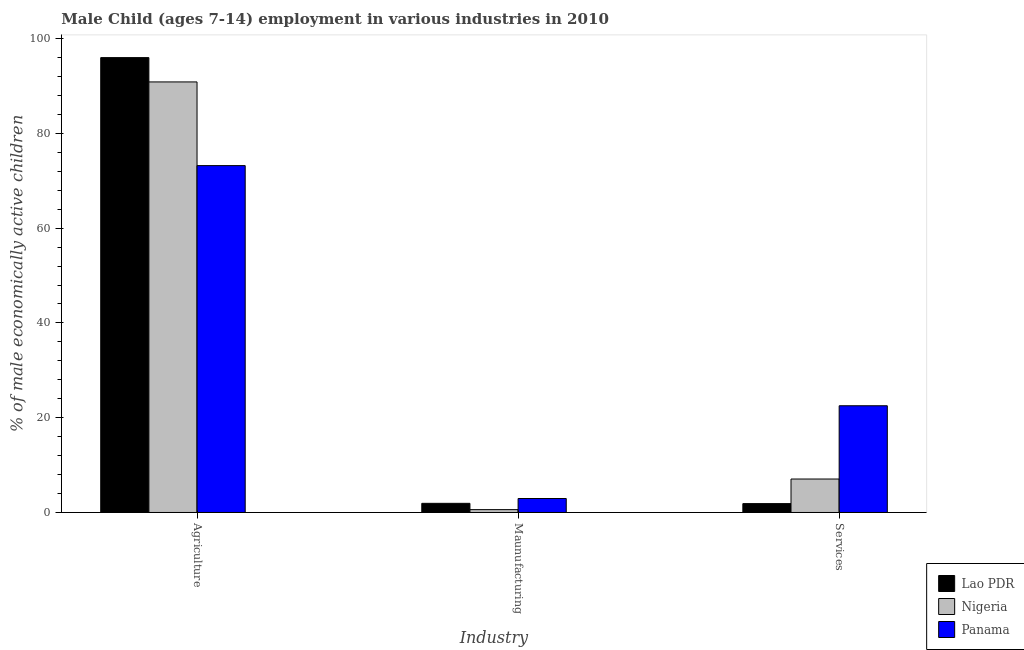How many groups of bars are there?
Provide a short and direct response. 3. Are the number of bars per tick equal to the number of legend labels?
Provide a succinct answer. Yes. How many bars are there on the 3rd tick from the left?
Give a very brief answer. 3. What is the label of the 3rd group of bars from the left?
Your answer should be compact. Services. What is the percentage of economically active children in services in Lao PDR?
Make the answer very short. 1.87. Across all countries, what is the maximum percentage of economically active children in agriculture?
Your response must be concise. 95.98. Across all countries, what is the minimum percentage of economically active children in services?
Offer a terse response. 1.87. In which country was the percentage of economically active children in services maximum?
Your answer should be compact. Panama. In which country was the percentage of economically active children in services minimum?
Make the answer very short. Lao PDR. What is the total percentage of economically active children in services in the graph?
Ensure brevity in your answer.  31.45. What is the difference between the percentage of economically active children in services in Lao PDR and that in Nigeria?
Keep it short and to the point. -5.19. What is the difference between the percentage of economically active children in agriculture in Panama and the percentage of economically active children in services in Nigeria?
Your answer should be compact. 66.13. What is the average percentage of economically active children in services per country?
Keep it short and to the point. 10.48. What is the difference between the percentage of economically active children in manufacturing and percentage of economically active children in services in Nigeria?
Your response must be concise. -6.46. What is the ratio of the percentage of economically active children in services in Panama to that in Nigeria?
Provide a short and direct response. 3.19. Is the difference between the percentage of economically active children in manufacturing in Nigeria and Lao PDR greater than the difference between the percentage of economically active children in agriculture in Nigeria and Lao PDR?
Your answer should be very brief. Yes. What is the difference between the highest and the second highest percentage of economically active children in manufacturing?
Ensure brevity in your answer.  1.02. What is the difference between the highest and the lowest percentage of economically active children in manufacturing?
Your response must be concise. 2.35. In how many countries, is the percentage of economically active children in agriculture greater than the average percentage of economically active children in agriculture taken over all countries?
Make the answer very short. 2. Is the sum of the percentage of economically active children in manufacturing in Lao PDR and Panama greater than the maximum percentage of economically active children in services across all countries?
Your answer should be compact. No. What does the 1st bar from the left in Agriculture represents?
Make the answer very short. Lao PDR. What does the 2nd bar from the right in Maunufacturing represents?
Ensure brevity in your answer.  Nigeria. Is it the case that in every country, the sum of the percentage of economically active children in agriculture and percentage of economically active children in manufacturing is greater than the percentage of economically active children in services?
Provide a succinct answer. Yes. How many bars are there?
Ensure brevity in your answer.  9. Are all the bars in the graph horizontal?
Your answer should be very brief. No. How many countries are there in the graph?
Provide a short and direct response. 3. What is the title of the graph?
Your answer should be very brief. Male Child (ages 7-14) employment in various industries in 2010. Does "French Polynesia" appear as one of the legend labels in the graph?
Keep it short and to the point. No. What is the label or title of the X-axis?
Provide a succinct answer. Industry. What is the label or title of the Y-axis?
Offer a very short reply. % of male economically active children. What is the % of male economically active children of Lao PDR in Agriculture?
Make the answer very short. 95.98. What is the % of male economically active children of Nigeria in Agriculture?
Give a very brief answer. 90.85. What is the % of male economically active children of Panama in Agriculture?
Offer a terse response. 73.19. What is the % of male economically active children of Lao PDR in Maunufacturing?
Ensure brevity in your answer.  1.93. What is the % of male economically active children of Nigeria in Maunufacturing?
Make the answer very short. 0.6. What is the % of male economically active children in Panama in Maunufacturing?
Your response must be concise. 2.95. What is the % of male economically active children of Lao PDR in Services?
Your response must be concise. 1.87. What is the % of male economically active children of Nigeria in Services?
Your answer should be compact. 7.06. What is the % of male economically active children of Panama in Services?
Keep it short and to the point. 22.52. Across all Industry, what is the maximum % of male economically active children in Lao PDR?
Your answer should be compact. 95.98. Across all Industry, what is the maximum % of male economically active children in Nigeria?
Your answer should be very brief. 90.85. Across all Industry, what is the maximum % of male economically active children of Panama?
Offer a terse response. 73.19. Across all Industry, what is the minimum % of male economically active children of Lao PDR?
Keep it short and to the point. 1.87. Across all Industry, what is the minimum % of male economically active children in Nigeria?
Provide a short and direct response. 0.6. Across all Industry, what is the minimum % of male economically active children in Panama?
Offer a terse response. 2.95. What is the total % of male economically active children in Lao PDR in the graph?
Offer a very short reply. 99.78. What is the total % of male economically active children of Nigeria in the graph?
Give a very brief answer. 98.51. What is the total % of male economically active children in Panama in the graph?
Your answer should be very brief. 98.66. What is the difference between the % of male economically active children of Lao PDR in Agriculture and that in Maunufacturing?
Your response must be concise. 94.05. What is the difference between the % of male economically active children in Nigeria in Agriculture and that in Maunufacturing?
Your answer should be very brief. 90.25. What is the difference between the % of male economically active children of Panama in Agriculture and that in Maunufacturing?
Provide a succinct answer. 70.24. What is the difference between the % of male economically active children of Lao PDR in Agriculture and that in Services?
Keep it short and to the point. 94.11. What is the difference between the % of male economically active children in Nigeria in Agriculture and that in Services?
Ensure brevity in your answer.  83.79. What is the difference between the % of male economically active children of Panama in Agriculture and that in Services?
Your response must be concise. 50.67. What is the difference between the % of male economically active children of Lao PDR in Maunufacturing and that in Services?
Give a very brief answer. 0.06. What is the difference between the % of male economically active children in Nigeria in Maunufacturing and that in Services?
Offer a terse response. -6.46. What is the difference between the % of male economically active children in Panama in Maunufacturing and that in Services?
Offer a terse response. -19.57. What is the difference between the % of male economically active children of Lao PDR in Agriculture and the % of male economically active children of Nigeria in Maunufacturing?
Give a very brief answer. 95.38. What is the difference between the % of male economically active children of Lao PDR in Agriculture and the % of male economically active children of Panama in Maunufacturing?
Keep it short and to the point. 93.03. What is the difference between the % of male economically active children of Nigeria in Agriculture and the % of male economically active children of Panama in Maunufacturing?
Your answer should be very brief. 87.9. What is the difference between the % of male economically active children in Lao PDR in Agriculture and the % of male economically active children in Nigeria in Services?
Offer a very short reply. 88.92. What is the difference between the % of male economically active children of Lao PDR in Agriculture and the % of male economically active children of Panama in Services?
Offer a very short reply. 73.46. What is the difference between the % of male economically active children of Nigeria in Agriculture and the % of male economically active children of Panama in Services?
Provide a succinct answer. 68.33. What is the difference between the % of male economically active children of Lao PDR in Maunufacturing and the % of male economically active children of Nigeria in Services?
Your answer should be compact. -5.13. What is the difference between the % of male economically active children in Lao PDR in Maunufacturing and the % of male economically active children in Panama in Services?
Your response must be concise. -20.59. What is the difference between the % of male economically active children in Nigeria in Maunufacturing and the % of male economically active children in Panama in Services?
Make the answer very short. -21.92. What is the average % of male economically active children of Lao PDR per Industry?
Your response must be concise. 33.26. What is the average % of male economically active children in Nigeria per Industry?
Your answer should be very brief. 32.84. What is the average % of male economically active children of Panama per Industry?
Provide a short and direct response. 32.89. What is the difference between the % of male economically active children of Lao PDR and % of male economically active children of Nigeria in Agriculture?
Ensure brevity in your answer.  5.13. What is the difference between the % of male economically active children in Lao PDR and % of male economically active children in Panama in Agriculture?
Make the answer very short. 22.79. What is the difference between the % of male economically active children of Nigeria and % of male economically active children of Panama in Agriculture?
Make the answer very short. 17.66. What is the difference between the % of male economically active children of Lao PDR and % of male economically active children of Nigeria in Maunufacturing?
Ensure brevity in your answer.  1.33. What is the difference between the % of male economically active children of Lao PDR and % of male economically active children of Panama in Maunufacturing?
Give a very brief answer. -1.02. What is the difference between the % of male economically active children of Nigeria and % of male economically active children of Panama in Maunufacturing?
Your response must be concise. -2.35. What is the difference between the % of male economically active children in Lao PDR and % of male economically active children in Nigeria in Services?
Give a very brief answer. -5.19. What is the difference between the % of male economically active children of Lao PDR and % of male economically active children of Panama in Services?
Your answer should be very brief. -20.65. What is the difference between the % of male economically active children in Nigeria and % of male economically active children in Panama in Services?
Your answer should be compact. -15.46. What is the ratio of the % of male economically active children of Lao PDR in Agriculture to that in Maunufacturing?
Offer a very short reply. 49.73. What is the ratio of the % of male economically active children of Nigeria in Agriculture to that in Maunufacturing?
Give a very brief answer. 151.42. What is the ratio of the % of male economically active children of Panama in Agriculture to that in Maunufacturing?
Offer a very short reply. 24.81. What is the ratio of the % of male economically active children of Lao PDR in Agriculture to that in Services?
Your answer should be very brief. 51.33. What is the ratio of the % of male economically active children of Nigeria in Agriculture to that in Services?
Ensure brevity in your answer.  12.87. What is the ratio of the % of male economically active children of Lao PDR in Maunufacturing to that in Services?
Offer a very short reply. 1.03. What is the ratio of the % of male economically active children in Nigeria in Maunufacturing to that in Services?
Your response must be concise. 0.09. What is the ratio of the % of male economically active children of Panama in Maunufacturing to that in Services?
Your answer should be compact. 0.13. What is the difference between the highest and the second highest % of male economically active children of Lao PDR?
Your answer should be very brief. 94.05. What is the difference between the highest and the second highest % of male economically active children in Nigeria?
Give a very brief answer. 83.79. What is the difference between the highest and the second highest % of male economically active children in Panama?
Your answer should be compact. 50.67. What is the difference between the highest and the lowest % of male economically active children of Lao PDR?
Provide a succinct answer. 94.11. What is the difference between the highest and the lowest % of male economically active children in Nigeria?
Provide a succinct answer. 90.25. What is the difference between the highest and the lowest % of male economically active children in Panama?
Offer a terse response. 70.24. 